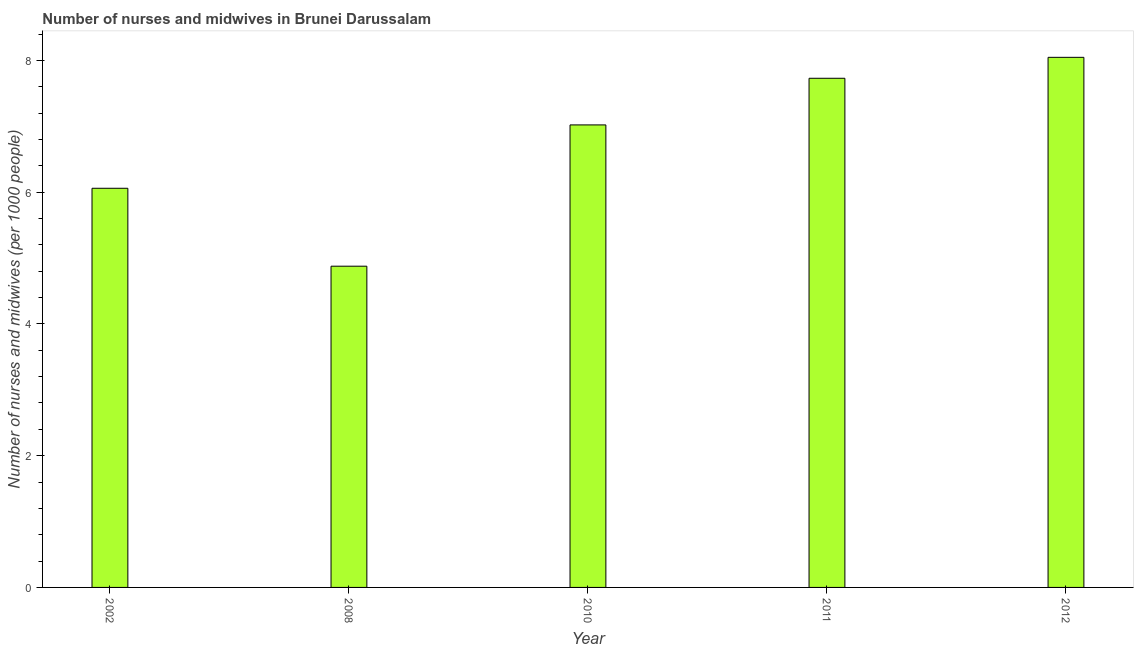Does the graph contain grids?
Provide a short and direct response. No. What is the title of the graph?
Keep it short and to the point. Number of nurses and midwives in Brunei Darussalam. What is the label or title of the Y-axis?
Ensure brevity in your answer.  Number of nurses and midwives (per 1000 people). What is the number of nurses and midwives in 2011?
Offer a very short reply. 7.73. Across all years, what is the maximum number of nurses and midwives?
Provide a short and direct response. 8.05. Across all years, what is the minimum number of nurses and midwives?
Ensure brevity in your answer.  4.88. What is the sum of the number of nurses and midwives?
Offer a terse response. 33.74. What is the difference between the number of nurses and midwives in 2008 and 2012?
Ensure brevity in your answer.  -3.17. What is the average number of nurses and midwives per year?
Keep it short and to the point. 6.75. What is the median number of nurses and midwives?
Provide a succinct answer. 7.02. In how many years, is the number of nurses and midwives greater than 1.6 ?
Provide a short and direct response. 5. Do a majority of the years between 2002 and 2008 (inclusive) have number of nurses and midwives greater than 4.4 ?
Offer a very short reply. Yes. What is the ratio of the number of nurses and midwives in 2002 to that in 2011?
Give a very brief answer. 0.78. Is the number of nurses and midwives in 2008 less than that in 2010?
Offer a very short reply. Yes. Is the difference between the number of nurses and midwives in 2010 and 2012 greater than the difference between any two years?
Your answer should be compact. No. What is the difference between the highest and the second highest number of nurses and midwives?
Your response must be concise. 0.32. Is the sum of the number of nurses and midwives in 2008 and 2011 greater than the maximum number of nurses and midwives across all years?
Give a very brief answer. Yes. What is the difference between the highest and the lowest number of nurses and midwives?
Provide a short and direct response. 3.17. How many bars are there?
Provide a short and direct response. 5. Are all the bars in the graph horizontal?
Provide a succinct answer. No. How many years are there in the graph?
Offer a very short reply. 5. What is the Number of nurses and midwives (per 1000 people) in 2002?
Give a very brief answer. 6.06. What is the Number of nurses and midwives (per 1000 people) in 2008?
Offer a very short reply. 4.88. What is the Number of nurses and midwives (per 1000 people) of 2010?
Make the answer very short. 7.02. What is the Number of nurses and midwives (per 1000 people) in 2011?
Give a very brief answer. 7.73. What is the Number of nurses and midwives (per 1000 people) of 2012?
Make the answer very short. 8.05. What is the difference between the Number of nurses and midwives (per 1000 people) in 2002 and 2008?
Your answer should be compact. 1.18. What is the difference between the Number of nurses and midwives (per 1000 people) in 2002 and 2010?
Your answer should be compact. -0.96. What is the difference between the Number of nurses and midwives (per 1000 people) in 2002 and 2011?
Give a very brief answer. -1.67. What is the difference between the Number of nurses and midwives (per 1000 people) in 2002 and 2012?
Your answer should be very brief. -1.99. What is the difference between the Number of nurses and midwives (per 1000 people) in 2008 and 2010?
Provide a short and direct response. -2.15. What is the difference between the Number of nurses and midwives (per 1000 people) in 2008 and 2011?
Your answer should be compact. -2.85. What is the difference between the Number of nurses and midwives (per 1000 people) in 2008 and 2012?
Your answer should be compact. -3.17. What is the difference between the Number of nurses and midwives (per 1000 people) in 2010 and 2011?
Give a very brief answer. -0.71. What is the difference between the Number of nurses and midwives (per 1000 people) in 2010 and 2012?
Give a very brief answer. -1.03. What is the difference between the Number of nurses and midwives (per 1000 people) in 2011 and 2012?
Your response must be concise. -0.32. What is the ratio of the Number of nurses and midwives (per 1000 people) in 2002 to that in 2008?
Provide a succinct answer. 1.24. What is the ratio of the Number of nurses and midwives (per 1000 people) in 2002 to that in 2010?
Keep it short and to the point. 0.86. What is the ratio of the Number of nurses and midwives (per 1000 people) in 2002 to that in 2011?
Your answer should be compact. 0.78. What is the ratio of the Number of nurses and midwives (per 1000 people) in 2002 to that in 2012?
Make the answer very short. 0.75. What is the ratio of the Number of nurses and midwives (per 1000 people) in 2008 to that in 2010?
Give a very brief answer. 0.69. What is the ratio of the Number of nurses and midwives (per 1000 people) in 2008 to that in 2011?
Give a very brief answer. 0.63. What is the ratio of the Number of nurses and midwives (per 1000 people) in 2008 to that in 2012?
Your answer should be very brief. 0.61. What is the ratio of the Number of nurses and midwives (per 1000 people) in 2010 to that in 2011?
Provide a short and direct response. 0.91. What is the ratio of the Number of nurses and midwives (per 1000 people) in 2010 to that in 2012?
Your answer should be compact. 0.87. 